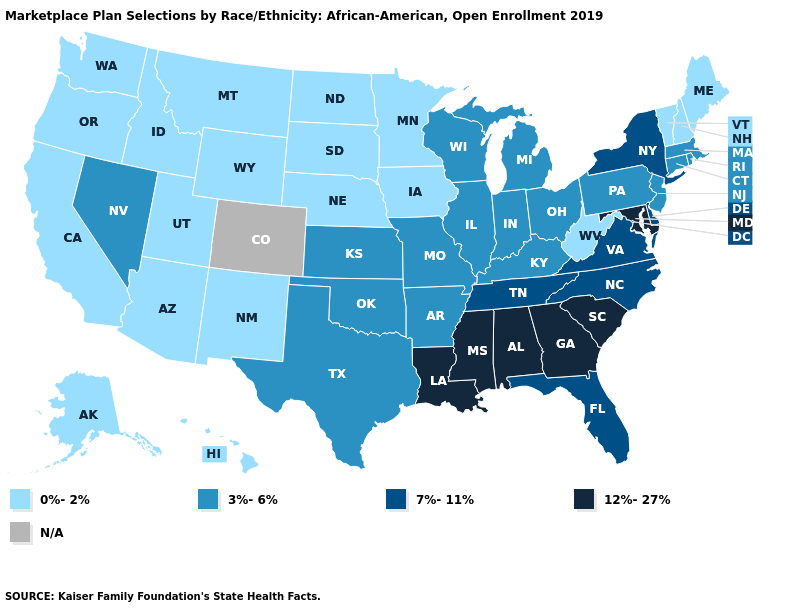Name the states that have a value in the range 12%-27%?
Write a very short answer. Alabama, Georgia, Louisiana, Maryland, Mississippi, South Carolina. Among the states that border Georgia , which have the highest value?
Concise answer only. Alabama, South Carolina. What is the lowest value in states that border Oklahoma?
Give a very brief answer. 0%-2%. Name the states that have a value in the range N/A?
Write a very short answer. Colorado. Does Alabama have the lowest value in the South?
Concise answer only. No. What is the value of Mississippi?
Concise answer only. 12%-27%. What is the value of Texas?
Keep it brief. 3%-6%. What is the highest value in the West ?
Short answer required. 3%-6%. Name the states that have a value in the range 0%-2%?
Short answer required. Alaska, Arizona, California, Hawaii, Idaho, Iowa, Maine, Minnesota, Montana, Nebraska, New Hampshire, New Mexico, North Dakota, Oregon, South Dakota, Utah, Vermont, Washington, West Virginia, Wyoming. Name the states that have a value in the range 0%-2%?
Answer briefly. Alaska, Arizona, California, Hawaii, Idaho, Iowa, Maine, Minnesota, Montana, Nebraska, New Hampshire, New Mexico, North Dakota, Oregon, South Dakota, Utah, Vermont, Washington, West Virginia, Wyoming. Does the first symbol in the legend represent the smallest category?
Short answer required. Yes. What is the value of Michigan?
Concise answer only. 3%-6%. Among the states that border North Dakota , which have the highest value?
Quick response, please. Minnesota, Montana, South Dakota. Which states have the lowest value in the USA?
Answer briefly. Alaska, Arizona, California, Hawaii, Idaho, Iowa, Maine, Minnesota, Montana, Nebraska, New Hampshire, New Mexico, North Dakota, Oregon, South Dakota, Utah, Vermont, Washington, West Virginia, Wyoming. Name the states that have a value in the range 0%-2%?
Write a very short answer. Alaska, Arizona, California, Hawaii, Idaho, Iowa, Maine, Minnesota, Montana, Nebraska, New Hampshire, New Mexico, North Dakota, Oregon, South Dakota, Utah, Vermont, Washington, West Virginia, Wyoming. 